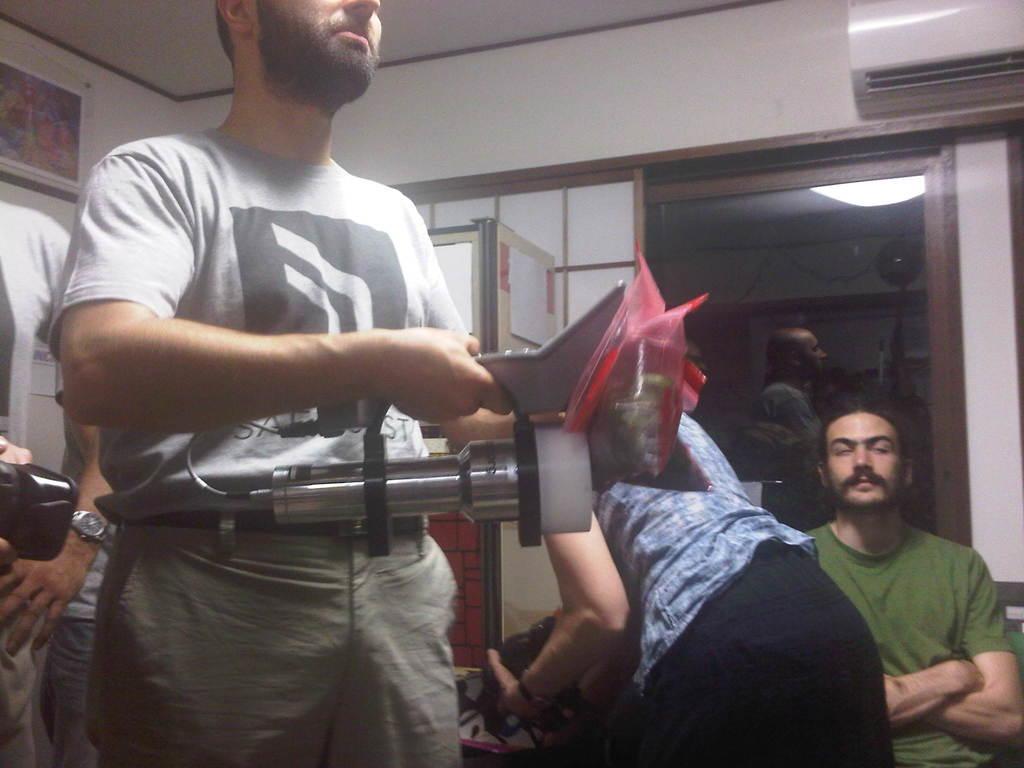Could you give a brief overview of what you see in this image? In the background we can see a glass and few objects and person is also visible. We can see a frame on the wall. We can see few notice papers and people in this picture. Few are holding devices in their hands. On the right side of the picture we can see a man wearing green t-shirt and it seems like he is sitting. In the top right corner we can see an air conditioner. 